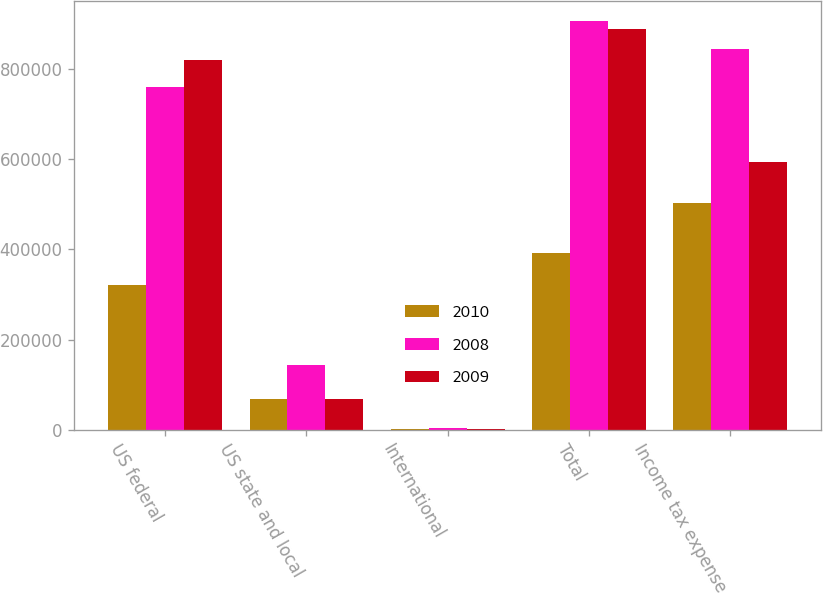Convert chart to OTSL. <chart><loc_0><loc_0><loc_500><loc_500><stacked_bar_chart><ecel><fcel>US federal<fcel>US state and local<fcel>International<fcel>Total<fcel>Income tax expense<nl><fcel>2010<fcel>320739<fcel>68313<fcel>2438<fcel>391490<fcel>504071<nl><fcel>2008<fcel>759683<fcel>143610<fcel>3415<fcel>906708<fcel>844713<nl><fcel>2009<fcel>820180<fcel>67696<fcel>907<fcel>888783<fcel>594692<nl></chart> 